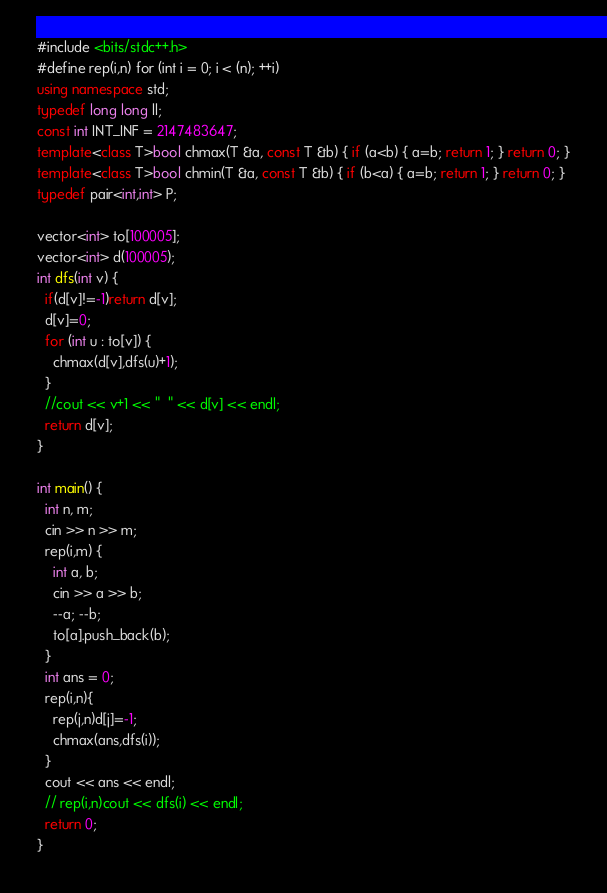<code> <loc_0><loc_0><loc_500><loc_500><_C++_>#include <bits/stdc++.h>
#define rep(i,n) for (int i = 0; i < (n); ++i)
using namespace std;
typedef long long ll;
const int INT_INF = 2147483647;
template<class T>bool chmax(T &a, const T &b) { if (a<b) { a=b; return 1; } return 0; }
template<class T>bool chmin(T &a, const T &b) { if (b<a) { a=b; return 1; } return 0; }
typedef pair<int,int> P;

vector<int> to[100005];
vector<int> d(100005);
int dfs(int v) {
  if(d[v]!=-1)return d[v];
  d[v]=0;
  for (int u : to[v]) {
    chmax(d[v],dfs(u)+1);
  }
  //cout << v+1 << "  " << d[v] << endl;
  return d[v];
}

int main() {
  int n, m;
  cin >> n >> m;
  rep(i,m) {
    int a, b;
    cin >> a >> b;
    --a; --b;
    to[a].push_back(b);
  }
  int ans = 0;
  rep(i,n){
    rep(j,n)d[j]=-1;
    chmax(ans,dfs(i));
  }
  cout << ans << endl;
  // rep(i,n)cout << dfs(i) << endl;
  return 0;
}
</code> 